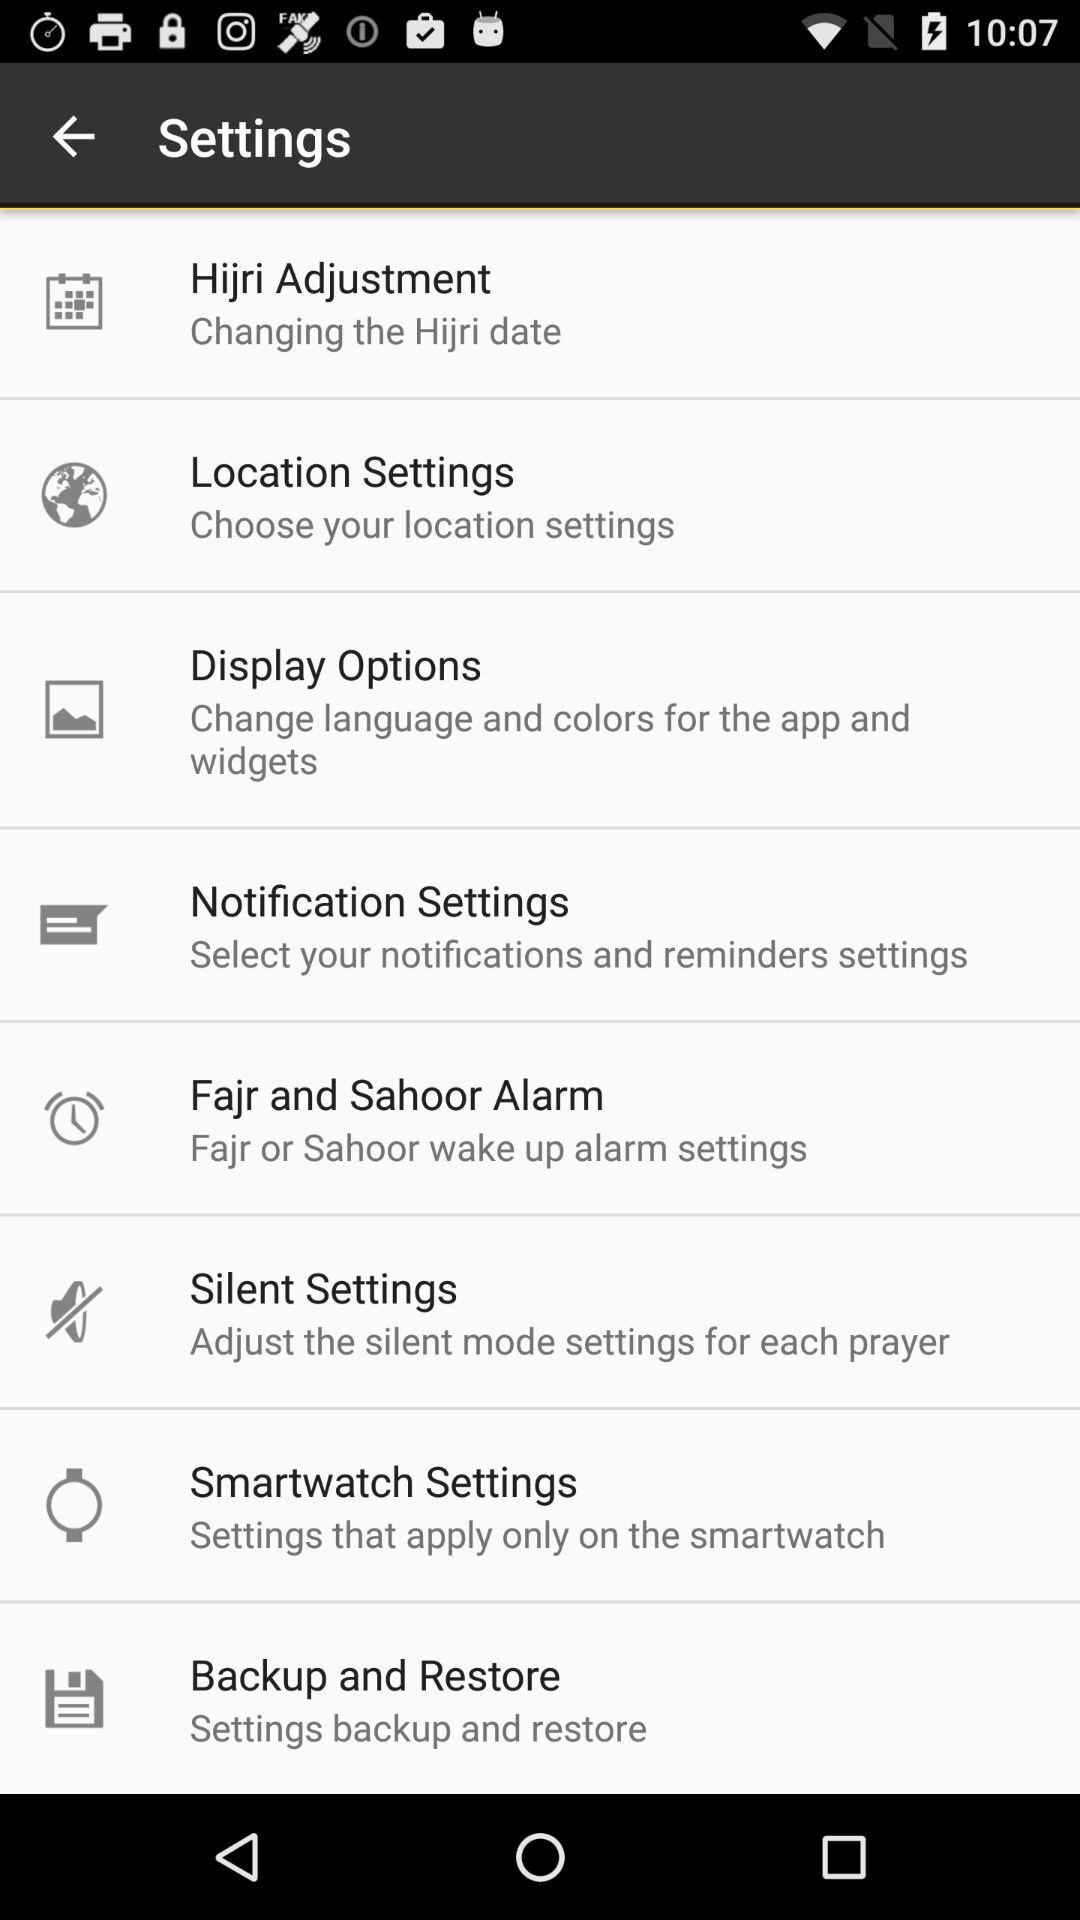How many settings options are there in the settings menu?
Answer the question using a single word or phrase. 8 